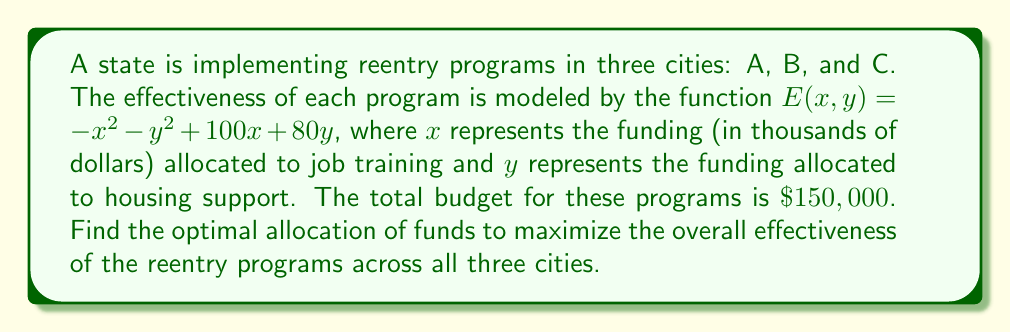Can you answer this question? 1) First, we need to find the maximum of the effectiveness function $E(x, y)$. To do this, we calculate the partial derivatives:

   $\frac{\partial E}{\partial x} = -2x + 100$
   $\frac{\partial E}{\partial y} = -2y + 80$

2) Setting these equal to zero:

   $-2x + 100 = 0$ and $-2y + 80 = 0$
   $x = 50$ and $y = 40$

3) This gives us the point of maximum effectiveness for each city: (50, 40)

4) The total funding for each city at this optimal point is:

   $50 + 40 = 90$ thousand dollars

5) Given our total budget of $\$150,000$, we can fully fund:

   $150 / 90 = 1.67$ cities

6) To maximize overall effectiveness, we should fully fund one city and distribute the remaining funds to a second city:

   City 1: $\$50,000$ for job training, $\$40,000$ for housing support
   City 2: $\$50,000$ for job training, $\$10,000$ for housing support
   City 3: $\$0$ for both programs

7) The effectiveness for each city:

   City 1: $E(50, 40) = -50^2 - 40^2 + 100(50) + 80(40) = 5700$
   City 2: $E(50, 10) = -50^2 - 10^2 + 100(50) + 80(10) = 4300$
   City 3: $E(0, 0) = 0$

8) Total effectiveness: $5700 + 4300 + 0 = 10000$
Answer: City 1: ($\$50,000$, $\$40,000$), City 2: ($\$50,000$, $\$10,000$), City 3: ($\$0$, $\$0$) 